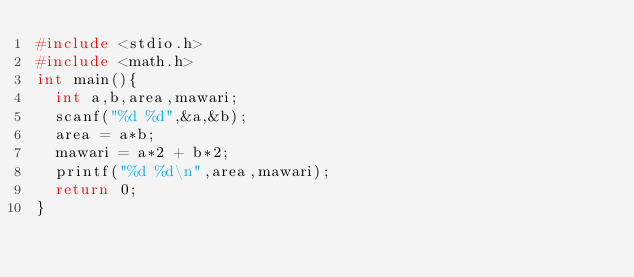Convert code to text. <code><loc_0><loc_0><loc_500><loc_500><_C_>#include <stdio.h>
#include <math.h>
int main(){
	int a,b,area,mawari;
	scanf("%d %d",&a,&b);
	area = a*b;
	mawari = a*2 + b*2;
	printf("%d %d\n",area,mawari);
	return 0;
}</code> 